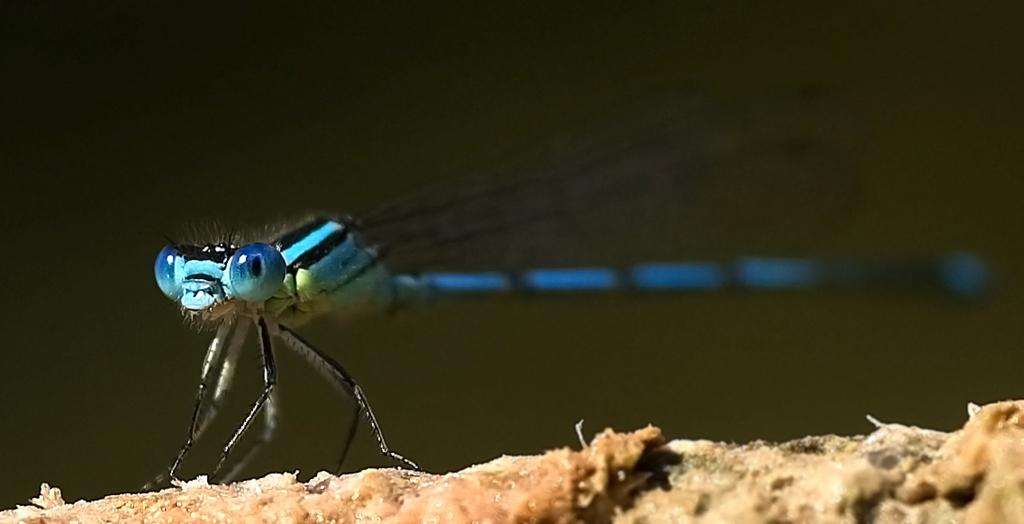What type of creature can be seen in the image? There is an insect in the image. Where is the insect located in the image? The insect is on the ground. What news headline is visible on the insect in the image? There is no news headline visible on the insect in the image, as it is an insect and not a medium for displaying news. 